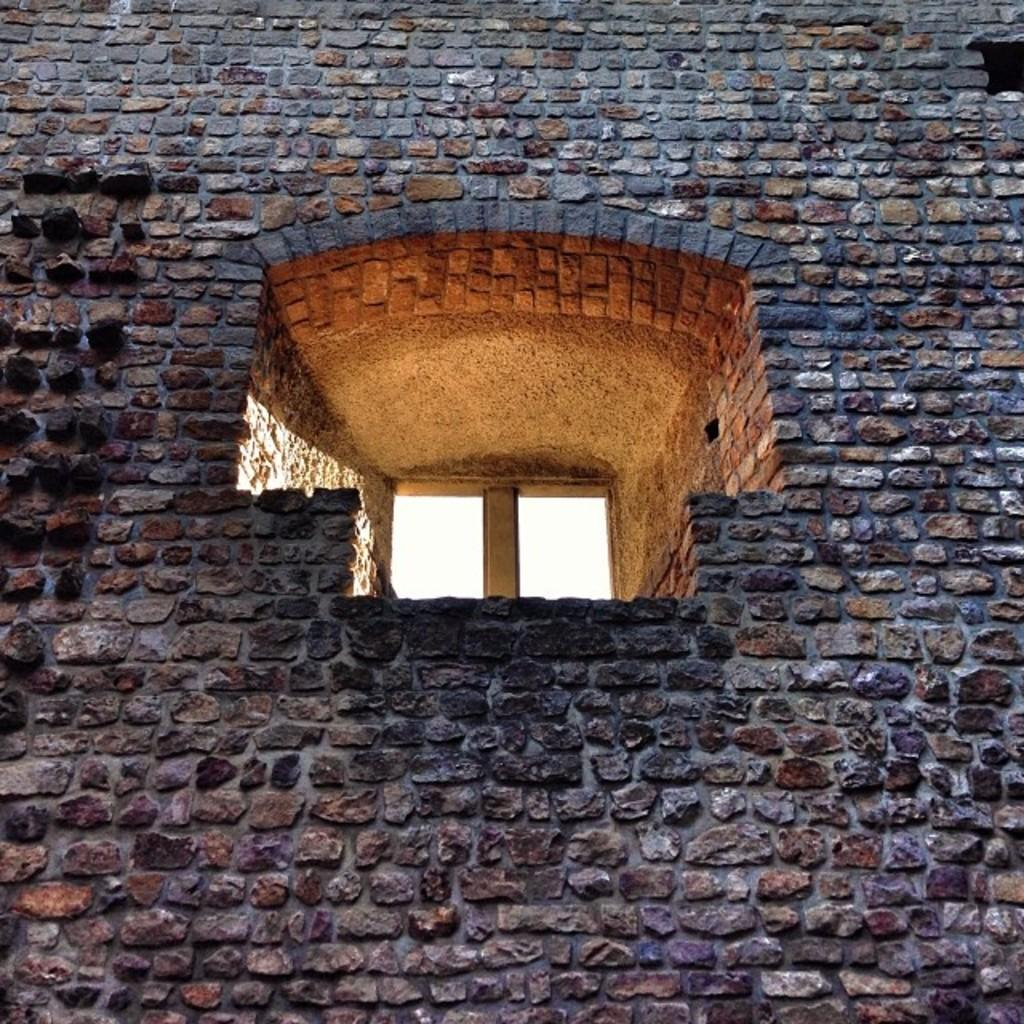What is located in the center of the image? There is a window and a wall in the center of the image. Can you describe the window in the image? The window is in the center of the image, but no further details about its appearance or condition are provided. What is the wall made of? The facts do not specify the material of the wall, so we cannot determine its composition. What type of mine is visible in the image? There is no mine present in the image; it only features a window and a wall. How far does the tank's range extend in the image? There is no tank present in the image, so we cannot determine its range. 